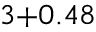Convert formula to latex. <formula><loc_0><loc_0><loc_500><loc_500>_ { 3 + 0 . 4 8 }</formula> 